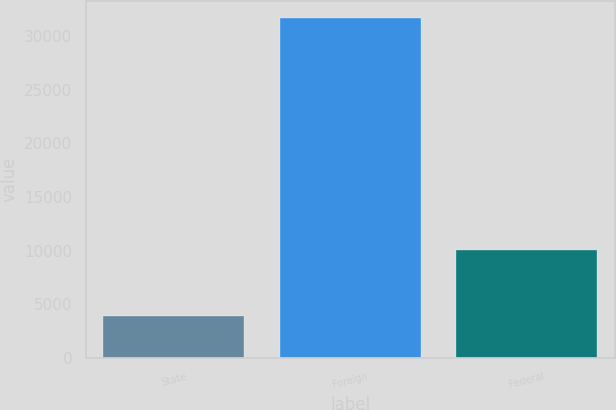<chart> <loc_0><loc_0><loc_500><loc_500><bar_chart><fcel>State<fcel>Foreign<fcel>Federal<nl><fcel>3954<fcel>31739<fcel>10083<nl></chart> 